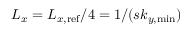Convert formula to latex. <formula><loc_0><loc_0><loc_500><loc_500>L _ { x } = L _ { x , r e f } / 4 = 1 / ( s k _ { y , \min } )</formula> 